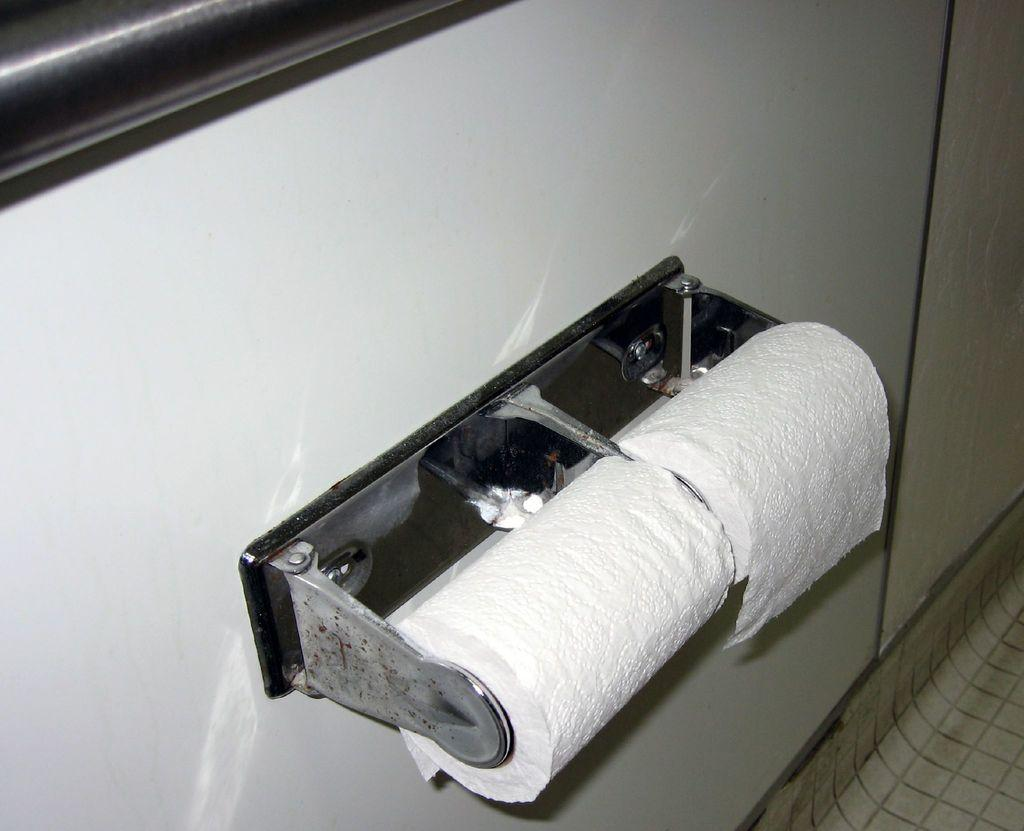What objects are in the image that are related to tissues? There are two white color tissue rolls in the image. How are the tissue rolls attached to the wall? The tissue rolls are fixed to the wall. What color is the wall in the image? The wall is in white color. What part of the room can be seen on the right side of the image? The floor is visible on the right side of the image. What type of yarn is being used to create a pattern on the sofa in the image? There is no sofa or yarn present in the image; it only features two white color tissue rolls fixed to a wall. What type of beef dish is being prepared on the floor in the image? There is no beef dish or cooking activity present in the image; it only shows the floor on the right side. 